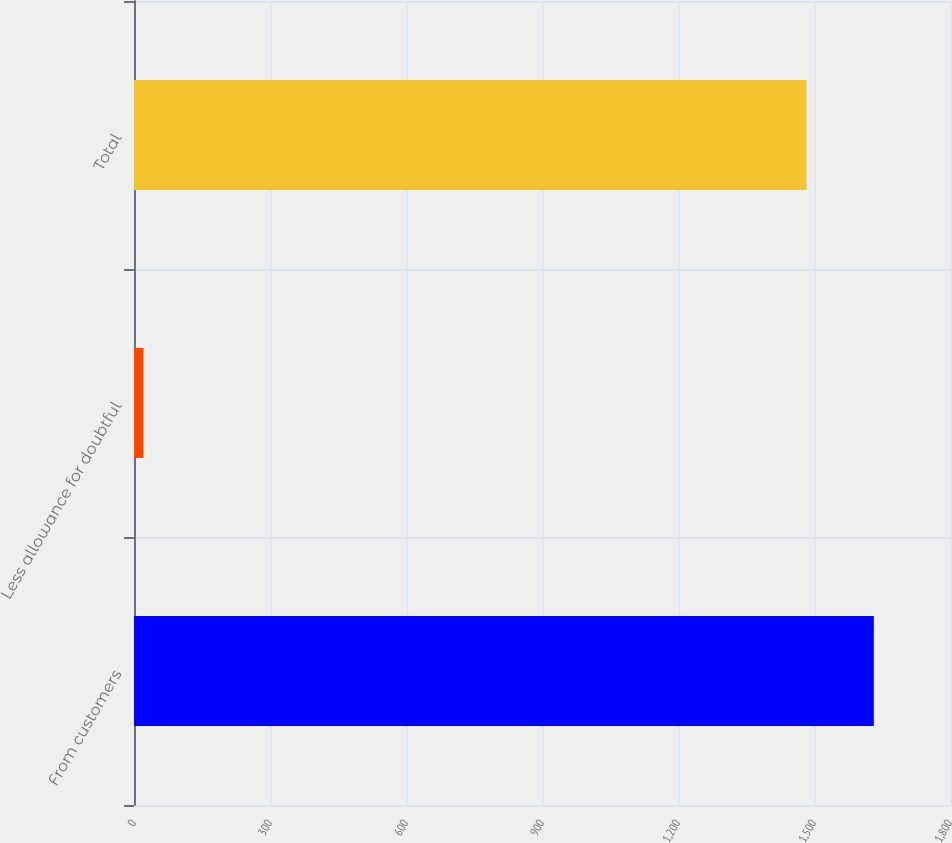<chart> <loc_0><loc_0><loc_500><loc_500><bar_chart><fcel>From customers<fcel>Less allowance for doubtful<fcel>Total<nl><fcel>1631.96<fcel>21<fcel>1483.6<nl></chart> 